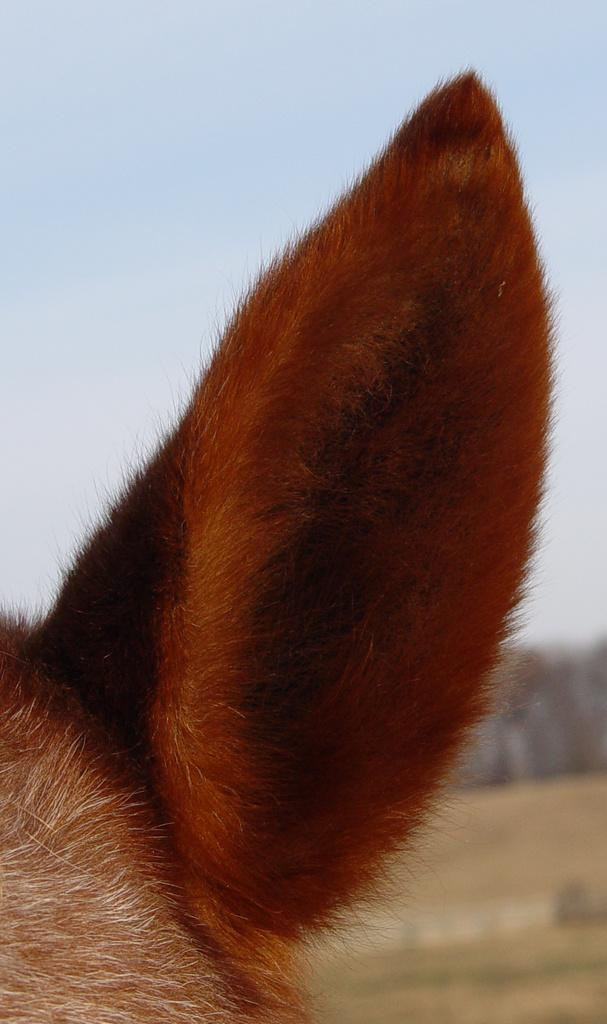What type of body part is featured in the image? There is an animal ear in the image. What can be seen in the background of the image? The ground and the sky are visible in the background of the image. How would you describe the overall appearance of the image? The image has a blurry appearance. What type of breakfast is being served in the image? There is no breakfast present in the image; it features an animal ear and a blurry background. 